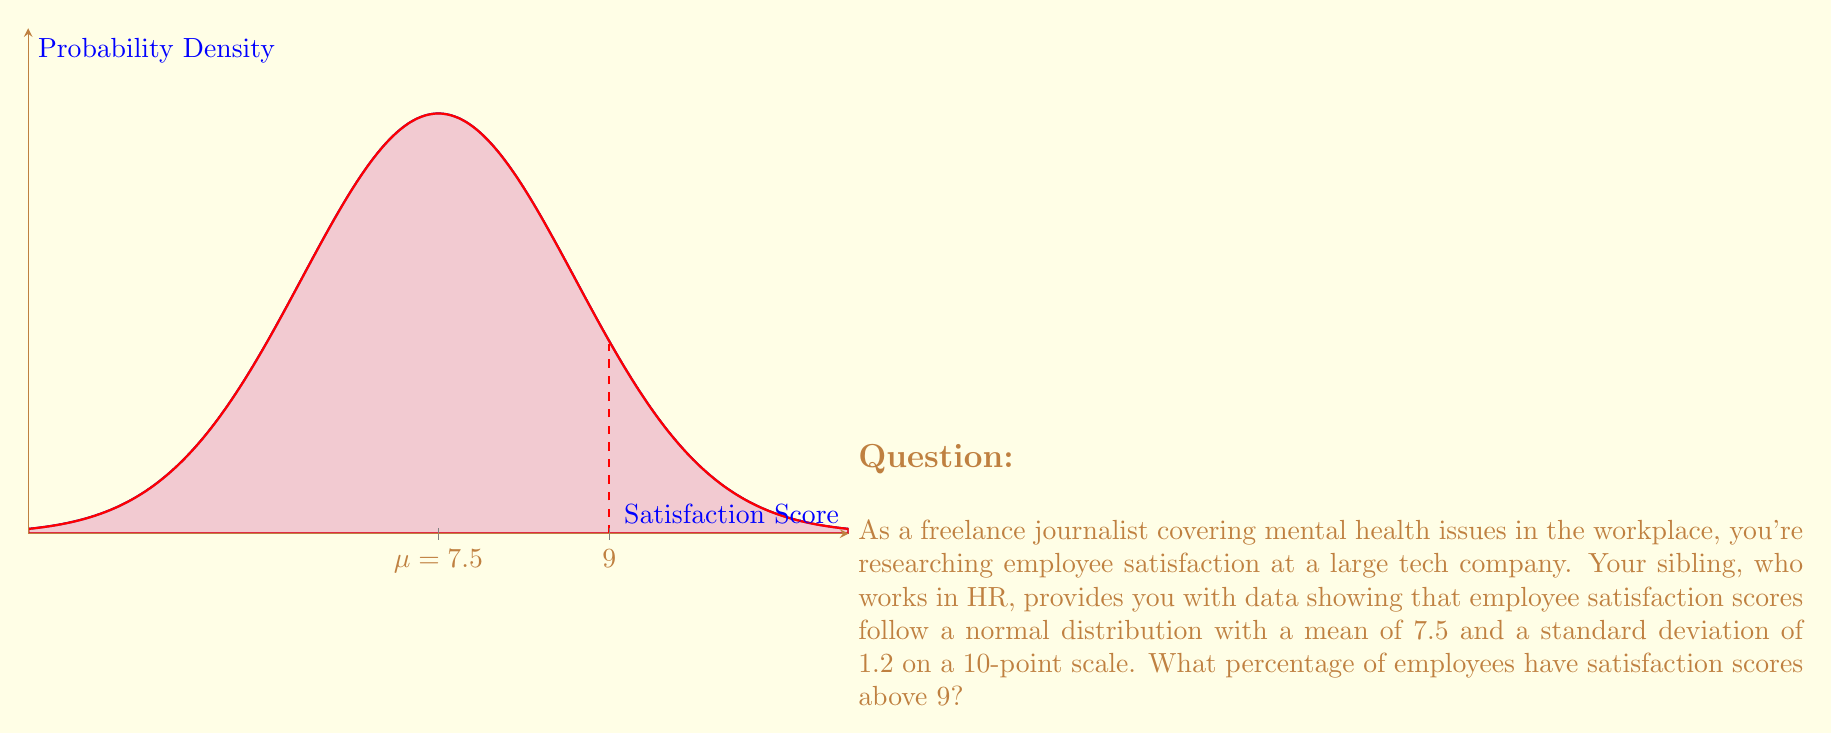Help me with this question. To solve this problem, we need to use the properties of the normal distribution and the concept of z-scores. Let's break it down step-by-step:

1) We're given:
   - Mean (μ) = 7.5
   - Standard deviation (σ) = 1.2
   - We want to find P(X > 9), where X is the satisfaction score

2) First, we need to calculate the z-score for a satisfaction score of 9:

   $$ z = \frac{x - μ}{σ} = \frac{9 - 7.5}{1.2} = \frac{1.5}{1.2} = 1.25 $$

3) Now, we need to find P(Z > 1.25), where Z is the standard normal variable

4) In a standard normal distribution:
   P(Z > 1.25) = 1 - P(Z < 1.25)

5) Using a standard normal table or calculator:
   P(Z < 1.25) ≈ 0.8944

6) Therefore:
   P(Z > 1.25) = 1 - 0.8944 = 0.1056

7) Convert to a percentage:
   0.1056 * 100 = 10.56%

Thus, approximately 10.56% of employees have satisfaction scores above 9.
Answer: 10.56% 